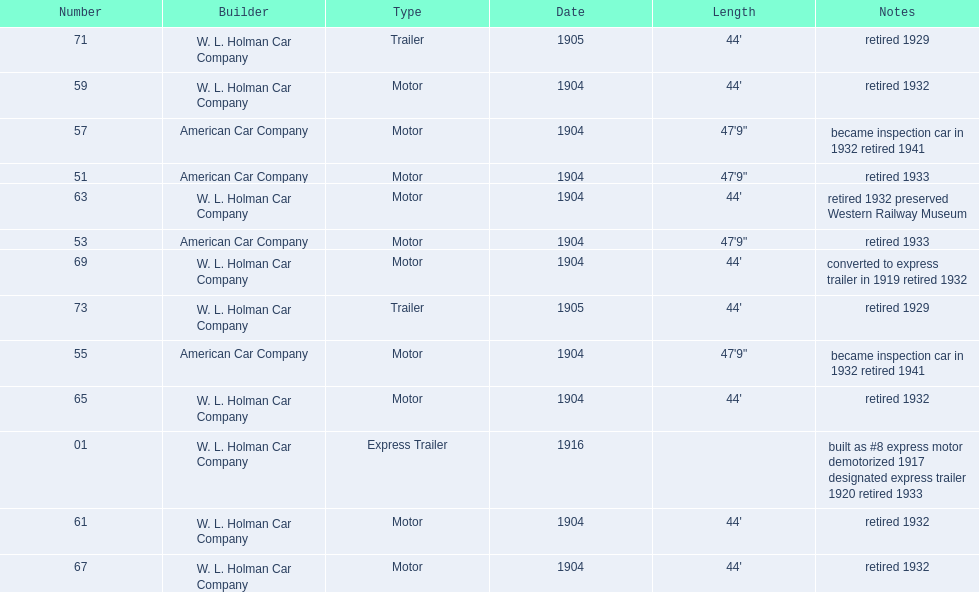In 1906, how many total rolling stock vehicles were in service? 12. 